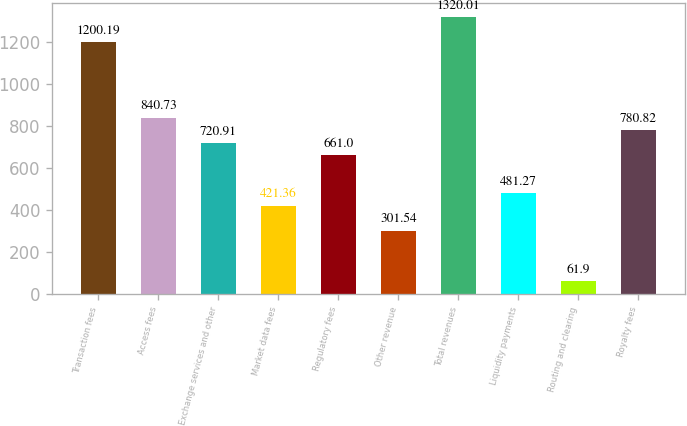Convert chart. <chart><loc_0><loc_0><loc_500><loc_500><bar_chart><fcel>Transaction fees<fcel>Access fees<fcel>Exchange services and other<fcel>Market data fees<fcel>Regulatory fees<fcel>Other revenue<fcel>Total revenues<fcel>Liquidity payments<fcel>Routing and clearing<fcel>Royalty fees<nl><fcel>1200.19<fcel>840.73<fcel>720.91<fcel>421.36<fcel>661<fcel>301.54<fcel>1320.01<fcel>481.27<fcel>61.9<fcel>780.82<nl></chart> 